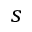<formula> <loc_0><loc_0><loc_500><loc_500>s</formula> 